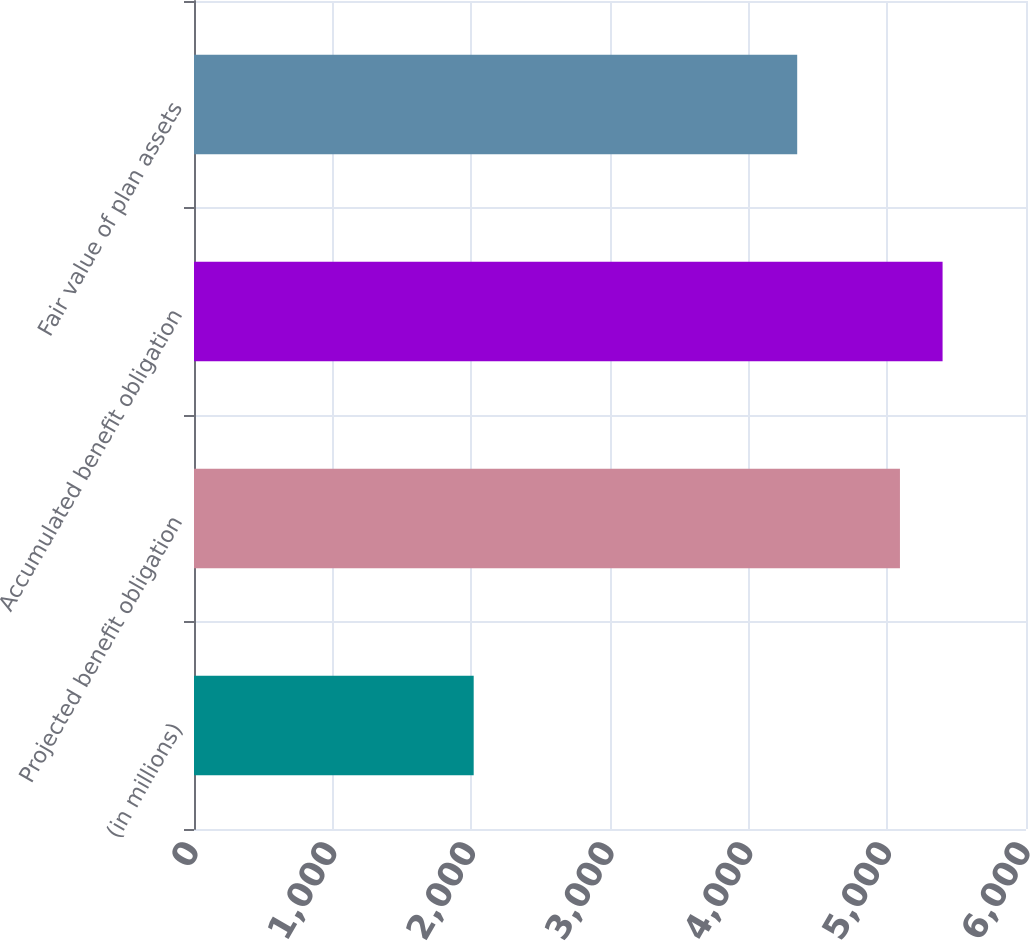<chart> <loc_0><loc_0><loc_500><loc_500><bar_chart><fcel>(in millions)<fcel>Projected benefit obligation<fcel>Accumulated benefit obligation<fcel>Fair value of plan assets<nl><fcel>2017<fcel>5091<fcel>5398.4<fcel>4350<nl></chart> 